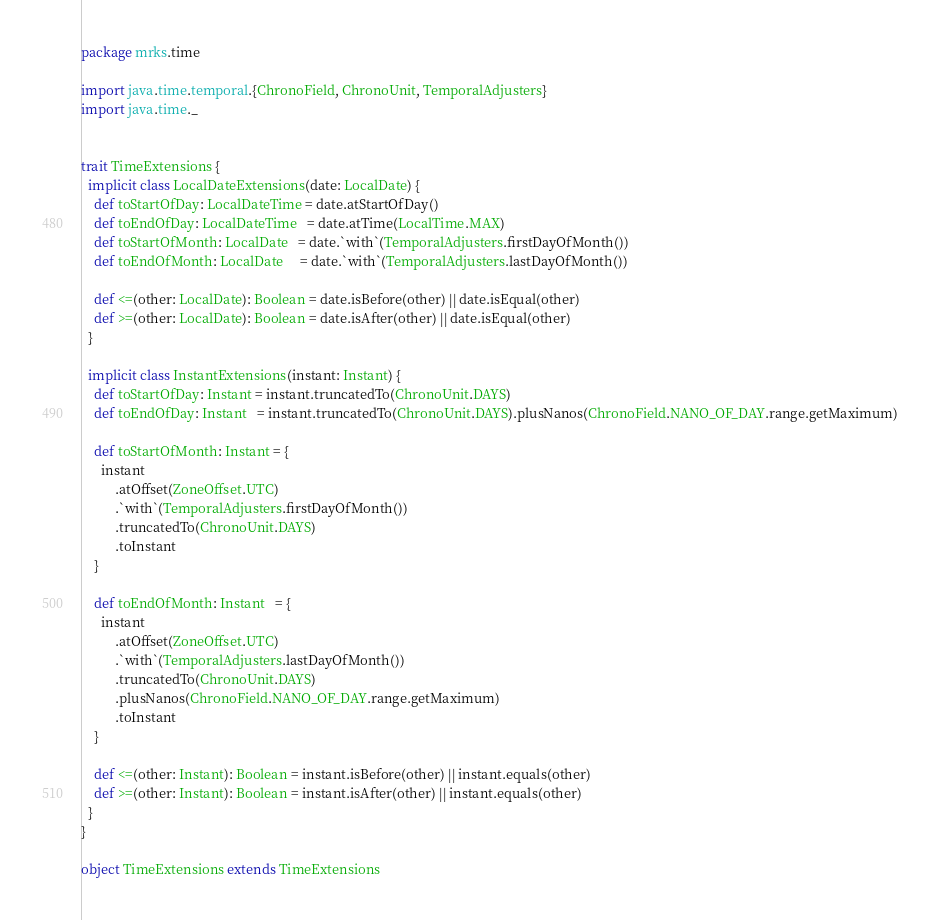Convert code to text. <code><loc_0><loc_0><loc_500><loc_500><_Scala_>package mrks.time

import java.time.temporal.{ChronoField, ChronoUnit, TemporalAdjusters}
import java.time._


trait TimeExtensions {
  implicit class LocalDateExtensions(date: LocalDate) {
    def toStartOfDay: LocalDateTime = date.atStartOfDay()
    def toEndOfDay: LocalDateTime   = date.atTime(LocalTime.MAX)
    def toStartOfMonth: LocalDate   = date.`with`(TemporalAdjusters.firstDayOfMonth())
    def toEndOfMonth: LocalDate     = date.`with`(TemporalAdjusters.lastDayOfMonth())

    def <=(other: LocalDate): Boolean = date.isBefore(other) || date.isEqual(other)
    def >=(other: LocalDate): Boolean = date.isAfter(other) || date.isEqual(other)
  }

  implicit class InstantExtensions(instant: Instant) {
    def toStartOfDay: Instant = instant.truncatedTo(ChronoUnit.DAYS)
    def toEndOfDay: Instant   = instant.truncatedTo(ChronoUnit.DAYS).plusNanos(ChronoField.NANO_OF_DAY.range.getMaximum)

    def toStartOfMonth: Instant = {
      instant
          .atOffset(ZoneOffset.UTC)
          .`with`(TemporalAdjusters.firstDayOfMonth())
          .truncatedTo(ChronoUnit.DAYS)
          .toInstant
    }

    def toEndOfMonth: Instant   = {
      instant
          .atOffset(ZoneOffset.UTC)
          .`with`(TemporalAdjusters.lastDayOfMonth())
          .truncatedTo(ChronoUnit.DAYS)
          .plusNanos(ChronoField.NANO_OF_DAY.range.getMaximum)
          .toInstant
    }

    def <=(other: Instant): Boolean = instant.isBefore(other) || instant.equals(other)
    def >=(other: Instant): Boolean = instant.isAfter(other) || instant.equals(other)
  }
}

object TimeExtensions extends TimeExtensions
</code> 